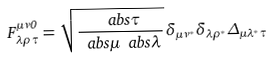<formula> <loc_0><loc_0><loc_500><loc_500>F _ { \lambda \rho \tau } ^ { \mu \nu 0 } = \sqrt { \frac { \ a b s { \tau } } { \ a b s { \mu } \ a b s { \lambda } } } \, \delta _ { \mu \nu ^ { \ast } } \delta _ { \lambda \rho ^ { \ast } } \Delta _ { \mu \lambda ^ { \ast } \tau }</formula> 